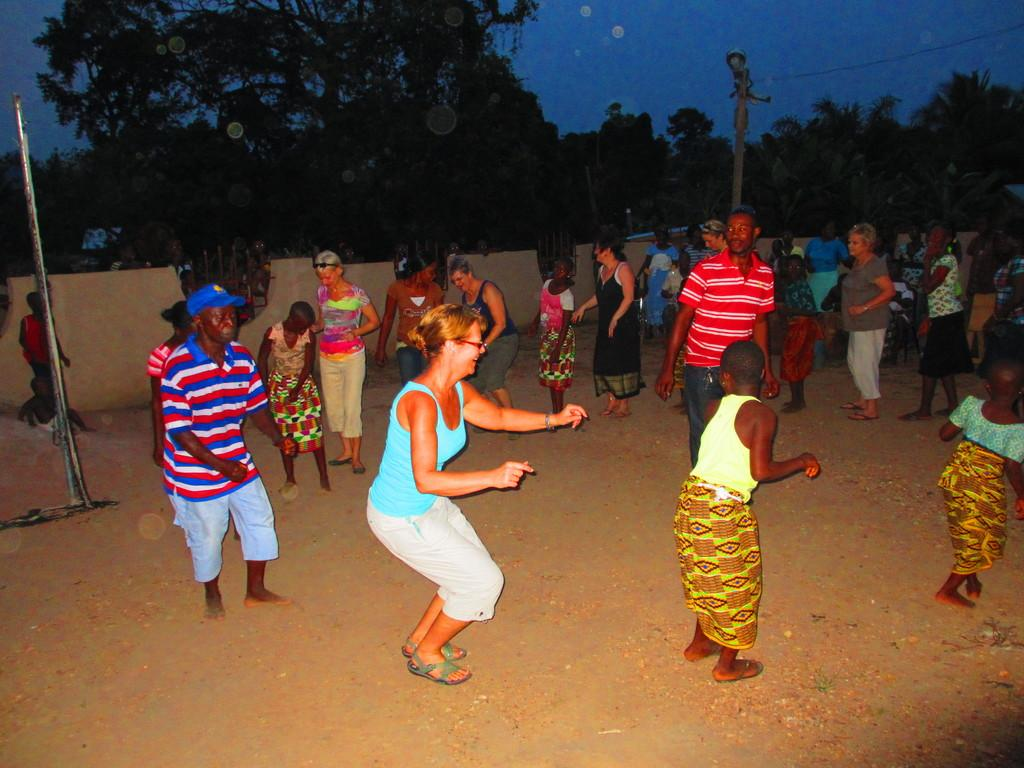How many people are in the image? There are people in the image, but the exact number is not specified. What is the surface on which the people are standing or performing? The ground is visible in the image, and some people are performing on it. What structures can be seen in the image? There are poles in the image. What is visible in the background of the image? The background of the image includes a wall, trees, and the sky. What type of star can be seen in the image? There is no star visible in the image. the image. --- Facts: 1. There is a car in the image. 2. The car is red. 3. The car has four wheels. 4. The car has a sunroof. 5. The car is parked on a street. Absurd Topics: unicorn, rainbow, magic wand Conversation: What type of vehicle is in the image? There is a car in the image. What color is the car? The car is red. How many wheels does the car have? The car has four wheels. What special feature does the car have? The car has a sunroof. Where is the car located in the image? The car is parked on a street. Reasoning: Let's think step by step in order to produce the conversation. We start by identifying the main subject of the image, which is the car. Next, we describe specific features of the car, such as its color, the number of wheels it has, and any special features it may possess. Then, we observe the car's location in the image, which is parked on a street. Finally, we ensure that the language used is simple and clear. Absurd Question/Answer: Can you see a unicorn in the image? There is no unicorn present in the image. --- Facts: 1. There is a dog in the image. 2. The dog is brown. 3. The dog is wagging its tail. 4. The dog is sitting on a grassy area. 5. There is a tree in the background of the image. Absurd Topics: flying saucer, alien creature, spacecraft Conversation: What type of animal is in the image? There is a dog in the image. What color is the dog? The dog is brown. What is the dog doing in the image? The dog is wagging its tail. Where is the dog located in the image? The dog is sitting on a grassy area. What can be seen in the background of the image? There is a tree in the background of the image. Reasoning: Let's think step by step in order to produce the conversation. We start by identifying the main subject of the image, which is the dog. 